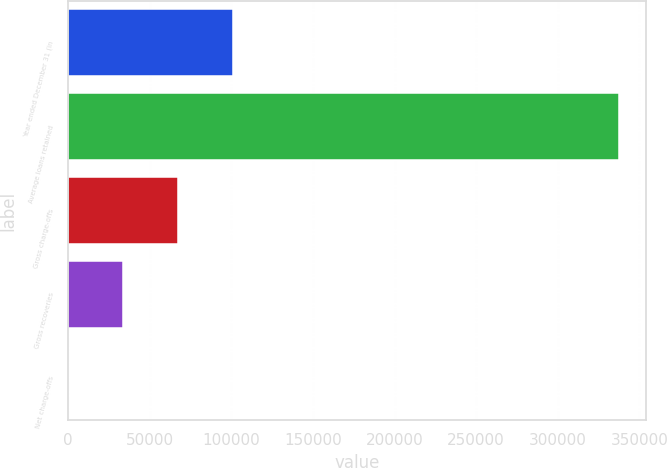Convert chart. <chart><loc_0><loc_0><loc_500><loc_500><bar_chart><fcel>Year ended December 31 (in<fcel>Average loans retained<fcel>Gross charge-offs<fcel>Gross recoveries<fcel>Net charge-offs<nl><fcel>101229<fcel>337407<fcel>67489.4<fcel>33749.7<fcel>10<nl></chart> 